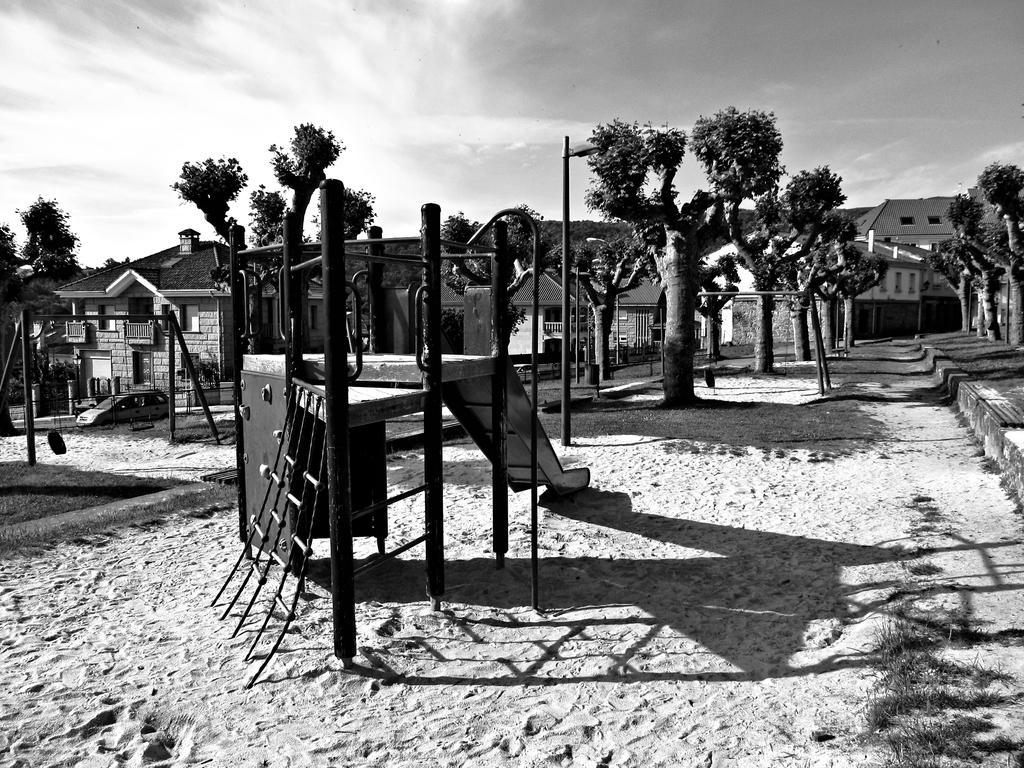Can you describe this image briefly? This is a black and white image, in this image in the center there are some houses, trees and in the foreground there is one slope. And at the bottom there is some sand and on the left side there is one car, and at the top of the image there is sky and also there are some poles in the center. 